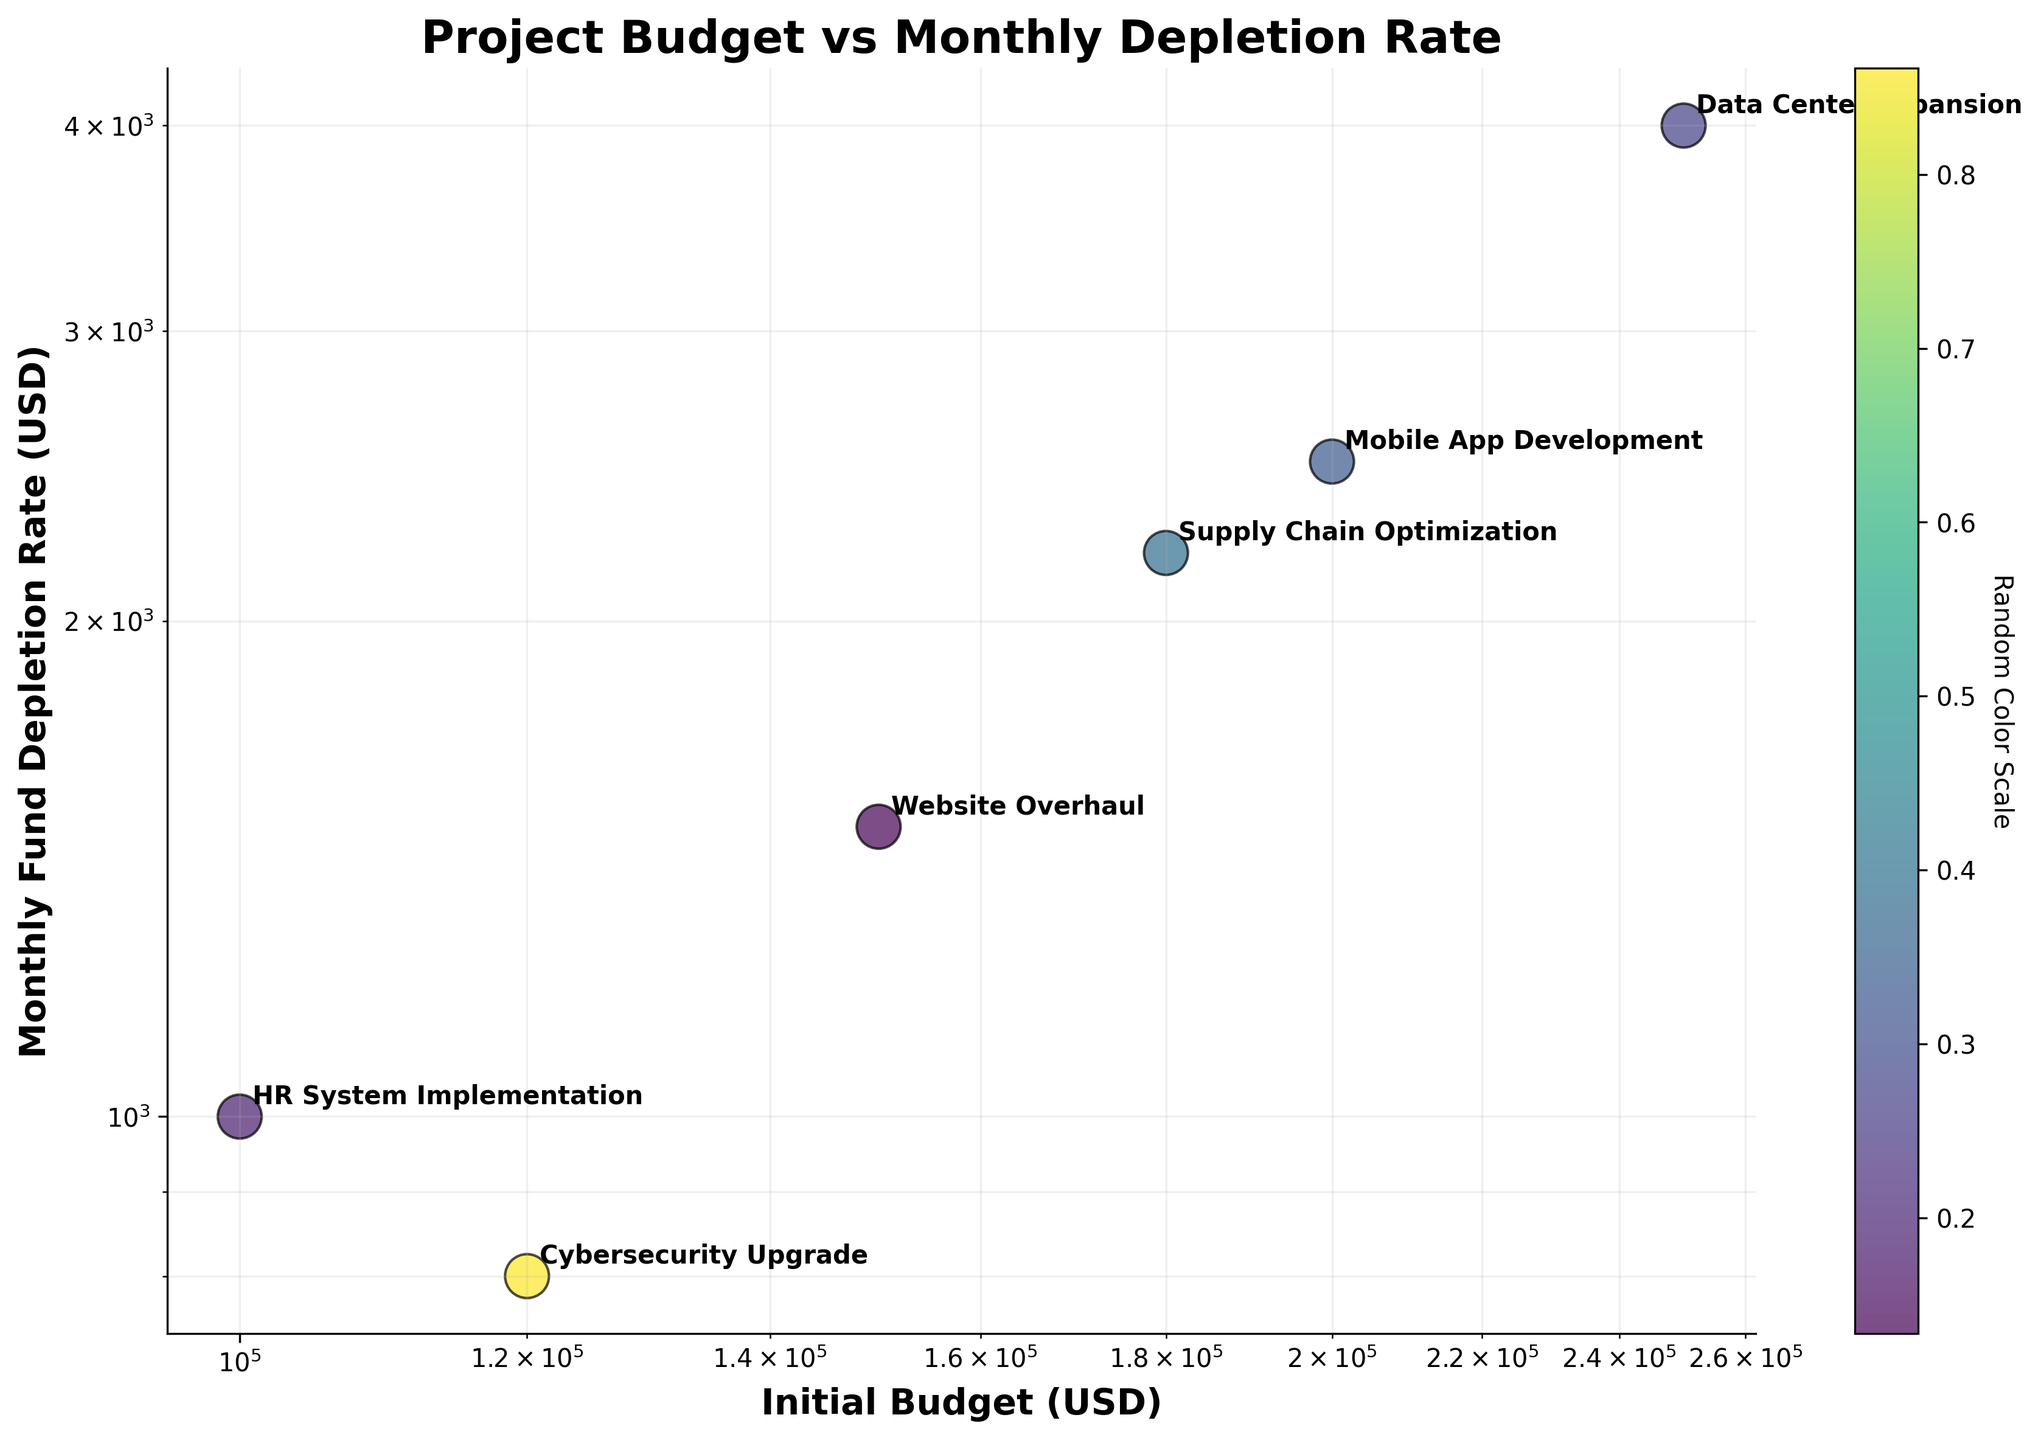What is the title of the figure? The title of the figure is displayed at the top of the chart. It summarizes the content and purpose of the plot. The title reads "Project Budget vs Monthly Depletion Rate."
Answer: Project Budget vs Monthly Depletion Rate What are the labels of the x and y axes? The x and y-axis labels are found along the horizontal and vertical axes of the plot, respectively. The x-axis label is "Initial Budget (USD)" and the y-axis label is "Monthly Fund Depletion Rate (USD)."
Answer: Initial Budget (USD) and Monthly Fund Depletion Rate (USD) Which project has the highest initial budget? To determine which project has the highest initial budget, examine the x-axis values. The point farthest to the right represents the highest budget. This is the "Data Center Expansion" project.
Answer: Data Center Expansion Which project has the lowest monthly fund depletion rate? To find the project with the lowest monthly fund depletion rate, locate the point closest to the bottom of the y-axis. This point represents the "Cybersecurity Upgrade" project with a rate of 800 USD.
Answer: Cybersecurity Upgrade How many projects have an initial budget greater than 150,000 USD? We need to count the number of data points to the right of the 150,000 USD mark on the x-axis. These projects are "Mobile App Development," "Data Center Expansion," and "Supply Chain Optimization." So, there are 3 projects.
Answer: 3 Which project has a monthly fund depletion rate closest to 3000 USD? Identify the point on the y-axis nearest to 3000 USD. By inspecting the plot, the "Data Center Expansion" project has a depletion rate near this value, specifically around 4000 USD.
Answer: Data Center Expansion How does the fund depletion rate of the "Website Overhaul" project compare to the "HR System Implementation" project? By comparing the points, see the position of "Website Overhaul" (1500 USD) to "HR System Implementation" (1000 USD) on the y-axis. "Website Overhaul" has a higher rate.
Answer: Website Overhaul has a higher rate Which project is represented by the point at approximately (180,000, 2200) in the plot? Cross-referencing the x and y coordinates on the plot, the point around (180,000, 2200) corresponds to the "Supply Chain Optimization" project.
Answer: Supply Chain Optimization What is the average initial budget of the projects plotted? Sum the initial budgets: 150,000 + 200,000 + 120,000 + 250,000 + 100,000 + 180,000 = 1,000,000 USD. Divide by the number of projects (6): 1,000,000 / 6 = 166,667 USD.
Answer: 166,667 USD 